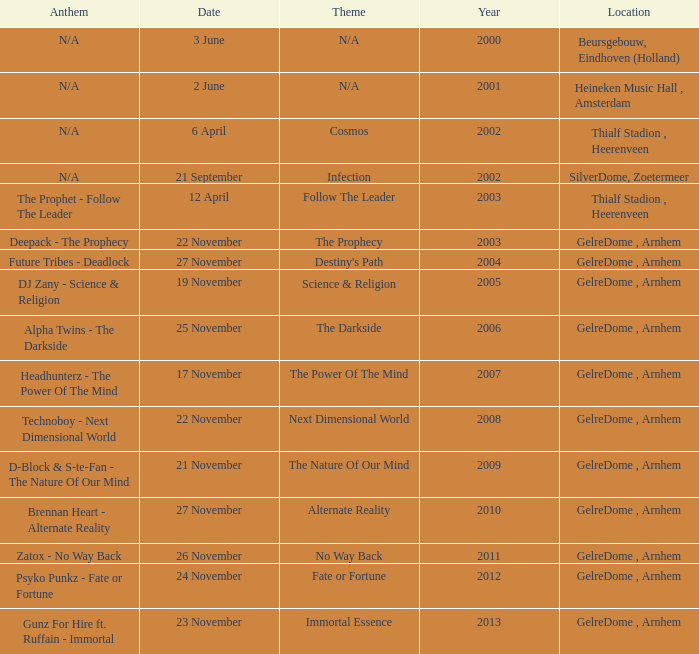What is the location in 2007? GelreDome , Arnhem. 